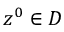Convert formula to latex. <formula><loc_0><loc_0><loc_500><loc_500>z ^ { 0 } \in D</formula> 